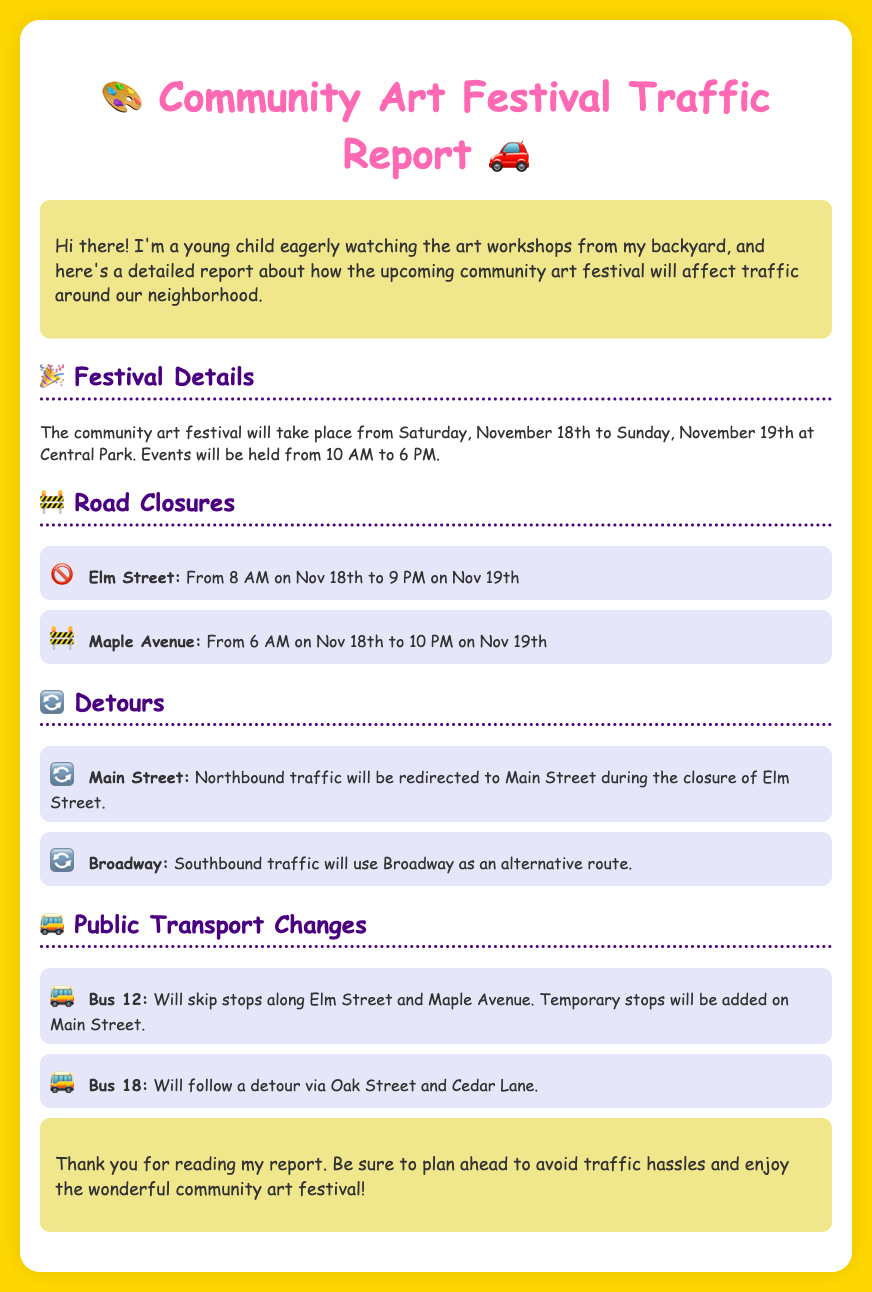What are the festival dates? The festival will take place from Saturday, November 18th to Sunday, November 19th.
Answer: November 18th to 19th What time does the festival start? The events will be held from 10 AM to 6 PM during the festival.
Answer: 10 AM Which street is closed first? The road closures start with Elm Street on November 18th.
Answer: Elm Street What is the last closure time for Maple Avenue? Maple Avenue will be closed until 10 PM on November 19th.
Answer: 10 PM Where will Bus 12 stop instead? Bus 12 will have temporary stops added on Main Street due to the closures.
Answer: Main Street What direction will northbound traffic take during Elm Street closure? Northbound traffic will be redirected to Main Street.
Answer: Main Street Which street will Bus 18 detour through? Bus 18 will follow a detour via Oak Street and Cedar Lane.
Answer: Oak Street and Cedar Lane What color is used for the report background? The background color of the report is a golden yellow.
Answer: Golden yellow How many hours is Elm Street closed? Elm Street will be closed for 37 hours in total.
Answer: 37 hours 